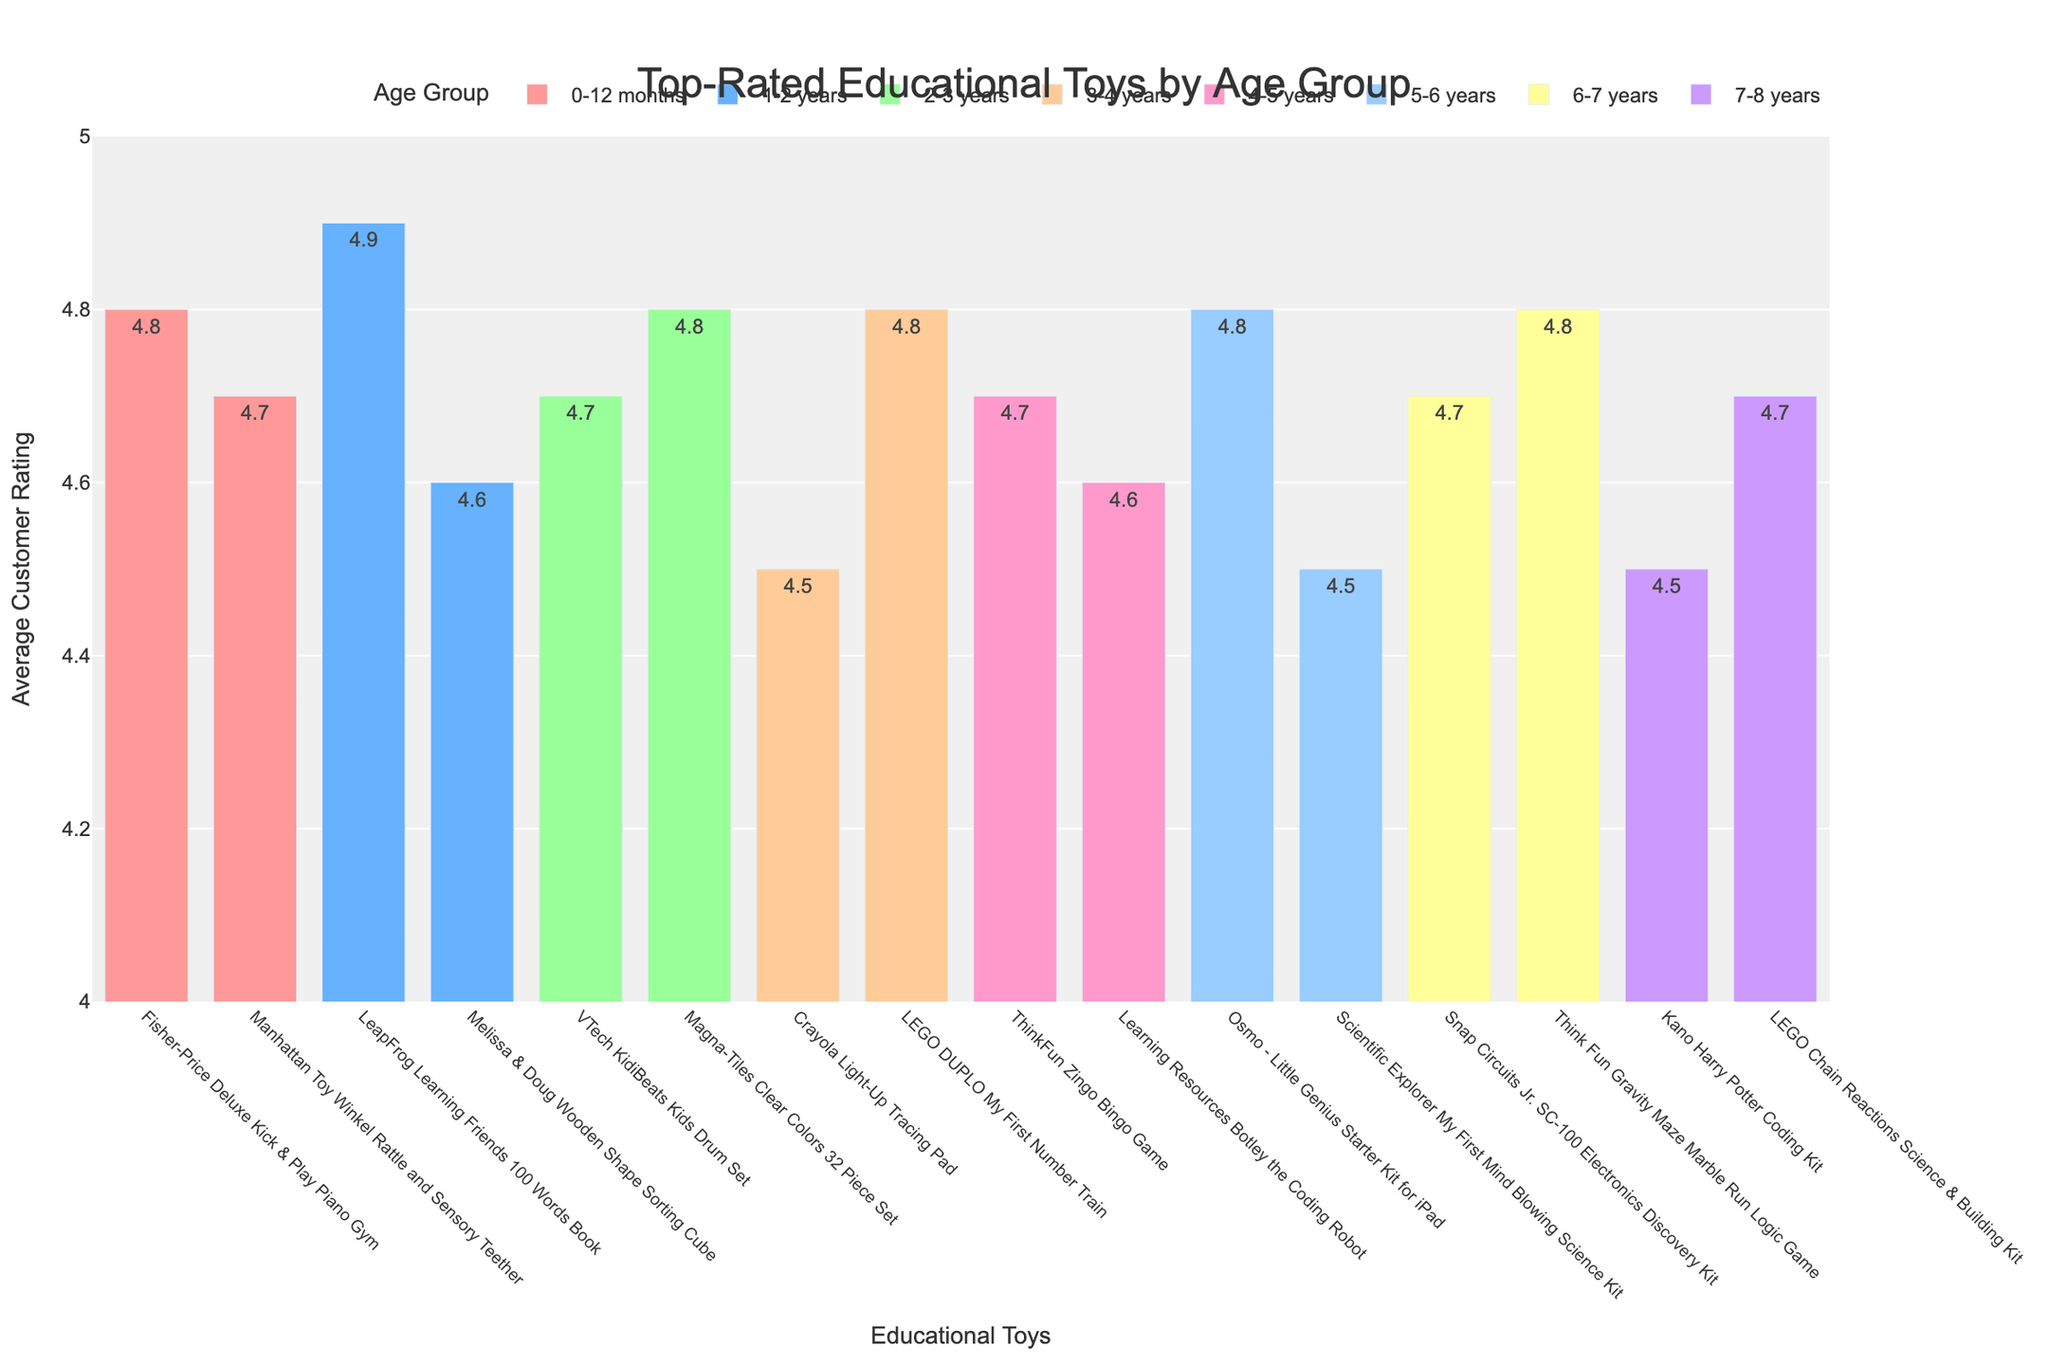Which educational toy for the 1-2 years age group has the highest average customer rating? Identify the age group section "1-2 years" and compare the ratings: LeapFrog Learning Friends 100 Words Book (4.9) and Melissa & Doug Wooden Shape Sorting Cube (4.6). The highest rating in this group is 4.9.
Answer: LeapFrog Learning Friends 100 Words Book What is the difference in average customer ratings between the Fisher-Price Deluxe Kick & Play Piano Gym and the Manhattan Toy Winkel Rattle and Sensory Teether? Look at the "0-12 months" age group, compare Fisher-Price Deluxe Kick & Play Piano Gym (4.8) and Manhattan Toy Winkel Rattle and Sensory Teether (4.7). Subtract the ratings: 4.8 - 4.7 = 0.1.
Answer: 0.1 Which educational toy in the 4-5 years age group has the lowest rating? Identify the age group "4-5 years" and compare the ratings: ThinkFun Zingo Bingo Game (4.7) and Learning Resources Botley the Coding Robot (4.6). The lowest rating in this group is 4.6.
Answer: Learning Resources Botley the Coding Robot How many toys have a rating of 4.8 across all age groups? Count the number of toys with an average customer rating of 4.8 by scanning each age group: Fisher-Price Deluxe Kick & Play Piano Gym, Magna-Tiles Clear Colors 32 Piece Set, LEGO DUPLO My First Number Train, Osmo - Little Genius Starter Kit for iPad, and Think Fun Gravity Maze Marble Run Logic Game. There are 5 toys.
Answer: 5 What is the average customer rating for the toys in the 6-7 years age group? Identify the toys in the "6-7 years" age group: Snap Circuits Jr. SC-100 Electronics Discovery Kit (4.7) and Think Fun Gravity Maze Marble Run Logic Game (4.8). Sum the ratings: 4.7 + 4.8 = 9.5. Divide by the number of toys (2): 9.5 / 2 = 4.75.
Answer: 4.75 